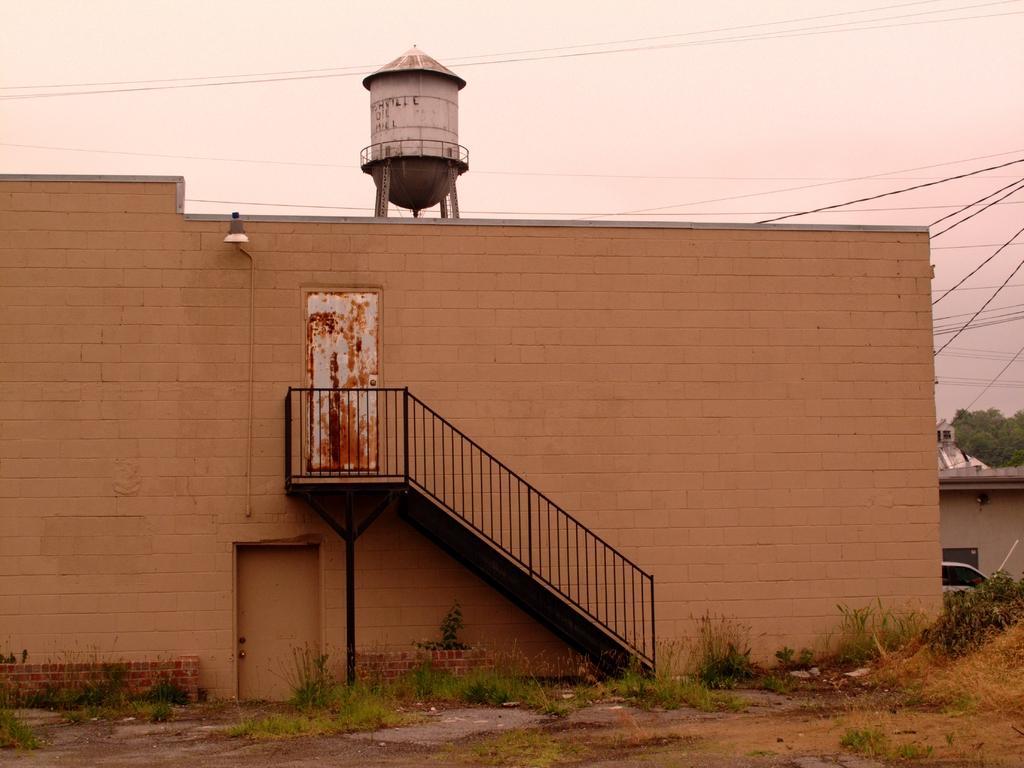How would you summarize this image in a sentence or two? In this image I can see the ground, some grass which is green in color on the ground, a building which is brown in color, the railing, the door and a water tank on the building. In the background I can see few wires, few trees and the sky. 